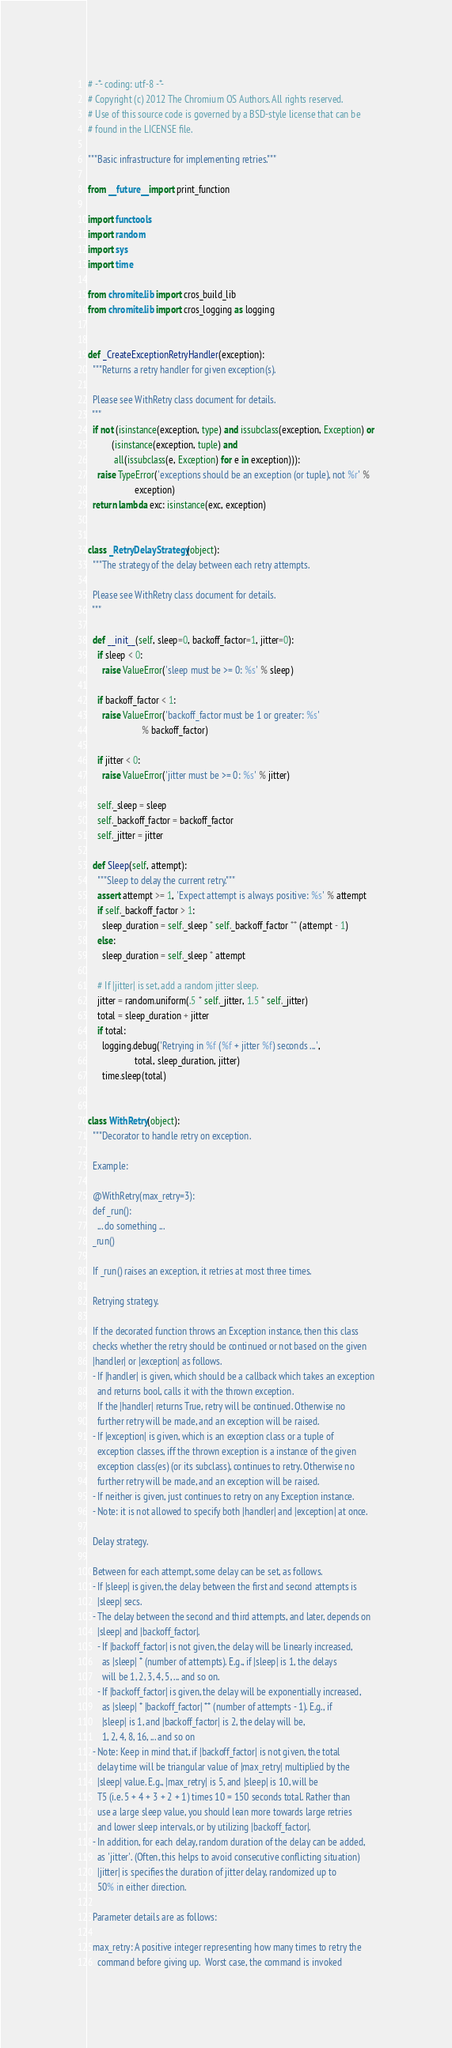<code> <loc_0><loc_0><loc_500><loc_500><_Python_># -*- coding: utf-8 -*-
# Copyright (c) 2012 The Chromium OS Authors. All rights reserved.
# Use of this source code is governed by a BSD-style license that can be
# found in the LICENSE file.

"""Basic infrastructure for implementing retries."""

from __future__ import print_function

import functools
import random
import sys
import time

from chromite.lib import cros_build_lib
from chromite.lib import cros_logging as logging


def _CreateExceptionRetryHandler(exception):
  """Returns a retry handler for given exception(s).

  Please see WithRetry class document for details.
  """
  if not (isinstance(exception, type) and issubclass(exception, Exception) or
          (isinstance(exception, tuple) and
           all(issubclass(e, Exception) for e in exception))):
    raise TypeError('exceptions should be an exception (or tuple), not %r' %
                    exception)
  return lambda exc: isinstance(exc, exception)


class _RetryDelayStrategy(object):
  """The strategy of the delay between each retry attempts.

  Please see WithRetry class document for details.
  """

  def __init__(self, sleep=0, backoff_factor=1, jitter=0):
    if sleep < 0:
      raise ValueError('sleep must be >= 0: %s' % sleep)

    if backoff_factor < 1:
      raise ValueError('backoff_factor must be 1 or greater: %s'
                       % backoff_factor)

    if jitter < 0:
      raise ValueError('jitter must be >= 0: %s' % jitter)

    self._sleep = sleep
    self._backoff_factor = backoff_factor
    self._jitter = jitter

  def Sleep(self, attempt):
    """Sleep to delay the current retry."""
    assert attempt >= 1, 'Expect attempt is always positive: %s' % attempt
    if self._backoff_factor > 1:
      sleep_duration = self._sleep * self._backoff_factor ** (attempt - 1)
    else:
      sleep_duration = self._sleep * attempt

    # If |jitter| is set, add a random jitter sleep.
    jitter = random.uniform(.5 * self._jitter, 1.5 * self._jitter)
    total = sleep_duration + jitter
    if total:
      logging.debug('Retrying in %f (%f + jitter %f) seconds ...',
                    total, sleep_duration, jitter)
      time.sleep(total)


class WithRetry(object):
  """Decorator to handle retry on exception.

  Example:

  @WithRetry(max_retry=3):
  def _run():
    ... do something ...
  _run()

  If _run() raises an exception, it retries at most three times.

  Retrying strategy.

  If the decorated function throws an Exception instance, then this class
  checks whether the retry should be continued or not based on the given
  |handler| or |exception| as follows.
  - If |handler| is given, which should be a callback which takes an exception
    and returns bool, calls it with the thrown exception.
    If the |handler| returns True, retry will be continued. Otherwise no
    further retry will be made, and an exception will be raised.
  - If |exception| is given, which is an exception class or a tuple of
    exception classes, iff the thrown exception is a instance of the given
    exception class(es) (or its subclass), continues to retry. Otherwise no
    further retry will be made, and an exception will be raised.
  - If neither is given, just continues to retry on any Exception instance.
  - Note: it is not allowed to specify both |handler| and |exception| at once.

  Delay strategy.

  Between for each attempt, some delay can be set, as follows.
  - If |sleep| is given, the delay between the first and second attempts is
    |sleep| secs.
  - The delay between the second and third attempts, and later, depends on
    |sleep| and |backoff_factor|.
    - If |backoff_factor| is not given, the delay will be linearly increased,
      as |sleep| * (number of attempts). E.g., if |sleep| is 1, the delays
      will be 1, 2, 3, 4, 5, ... and so on.
    - If |backoff_factor| is given, the delay will be exponentially increased,
      as |sleep| * |backoff_factor| ** (number of attempts - 1). E.g., if
      |sleep| is 1, and |backoff_factor| is 2, the delay will be,
      1, 2, 4, 8, 16, ... and so on
  - Note: Keep in mind that, if |backoff_factor| is not given, the total
    delay time will be triangular value of |max_retry| multiplied by the
    |sleep| value. E.g., |max_retry| is 5, and |sleep| is 10, will be
    T5 (i.e. 5 + 4 + 3 + 2 + 1) times 10 = 150 seconds total. Rather than
    use a large sleep value, you should lean more towards large retries
    and lower sleep intervals, or by utilizing |backoff_factor|.
  - In addition, for each delay, random duration of the delay can be added,
    as 'jitter'. (Often, this helps to avoid consecutive conflicting situation)
    |jitter| is specifies the duration of jitter delay, randomized up to
    50% in either direction.

  Parameter details are as follows:

  max_retry: A positive integer representing how many times to retry the
    command before giving up.  Worst case, the command is invoked</code> 